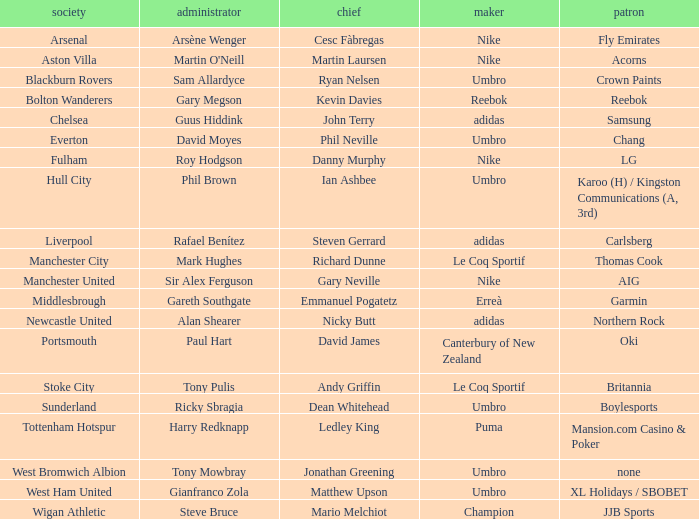Who is Dean Whitehead's manager? Ricky Sbragia. 